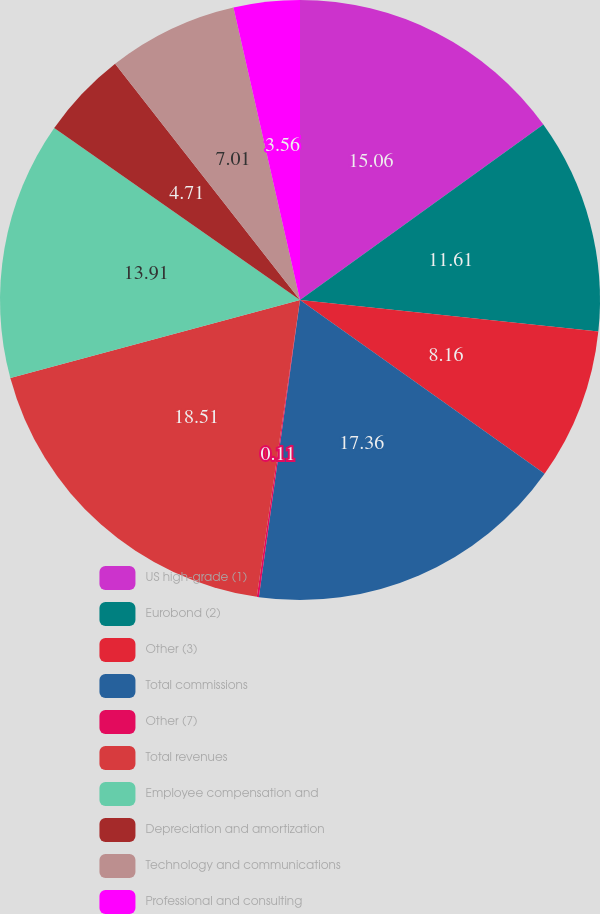Convert chart. <chart><loc_0><loc_0><loc_500><loc_500><pie_chart><fcel>US high-grade (1)<fcel>Eurobond (2)<fcel>Other (3)<fcel>Total commissions<fcel>Other (7)<fcel>Total revenues<fcel>Employee compensation and<fcel>Depreciation and amortization<fcel>Technology and communications<fcel>Professional and consulting<nl><fcel>15.06%<fcel>11.61%<fcel>8.16%<fcel>17.36%<fcel>0.11%<fcel>18.51%<fcel>13.91%<fcel>4.71%<fcel>7.01%<fcel>3.56%<nl></chart> 